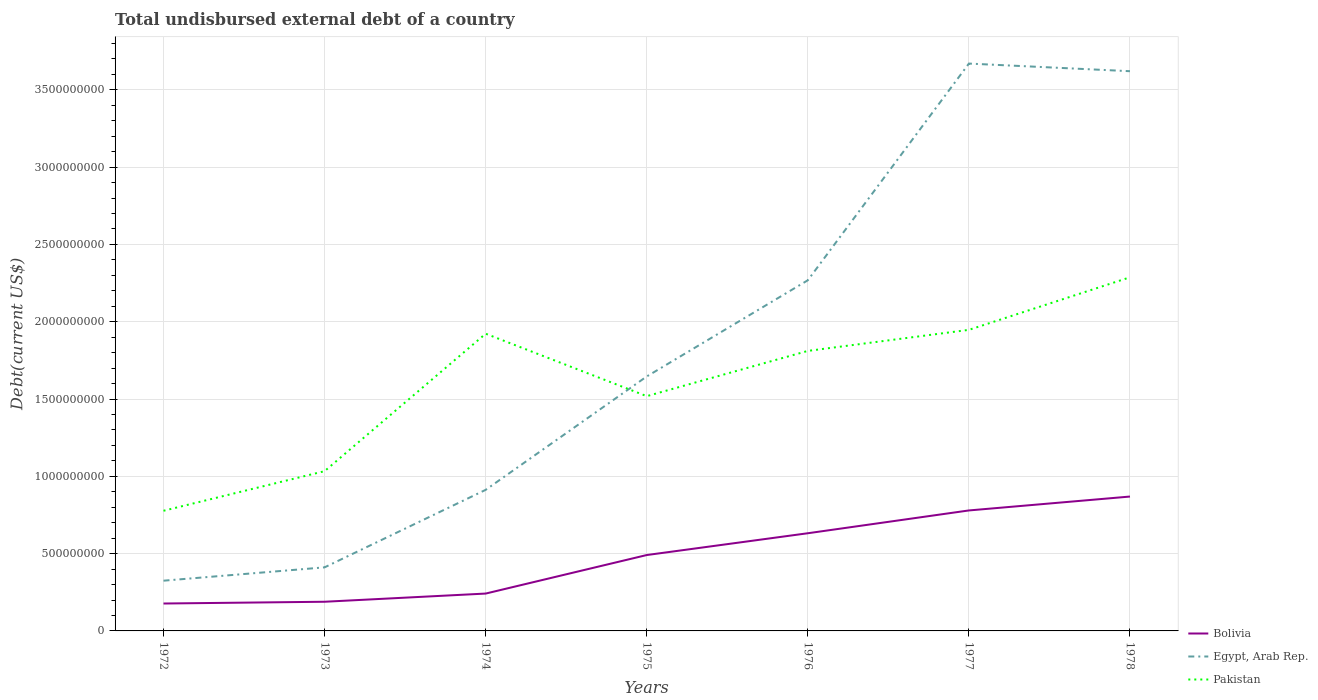Does the line corresponding to Bolivia intersect with the line corresponding to Pakistan?
Your response must be concise. No. Across all years, what is the maximum total undisbursed external debt in Egypt, Arab Rep.?
Offer a very short reply. 3.25e+08. In which year was the total undisbursed external debt in Egypt, Arab Rep. maximum?
Keep it short and to the point. 1972. What is the total total undisbursed external debt in Egypt, Arab Rep. in the graph?
Keep it short and to the point. -1.94e+09. What is the difference between the highest and the second highest total undisbursed external debt in Pakistan?
Your response must be concise. 1.51e+09. What is the difference between the highest and the lowest total undisbursed external debt in Pakistan?
Your answer should be very brief. 4. How many years are there in the graph?
Offer a terse response. 7. What is the difference between two consecutive major ticks on the Y-axis?
Keep it short and to the point. 5.00e+08. Does the graph contain any zero values?
Make the answer very short. No. Does the graph contain grids?
Provide a succinct answer. Yes. Where does the legend appear in the graph?
Your response must be concise. Bottom right. How many legend labels are there?
Make the answer very short. 3. What is the title of the graph?
Offer a terse response. Total undisbursed external debt of a country. Does "Brunei Darussalam" appear as one of the legend labels in the graph?
Give a very brief answer. No. What is the label or title of the X-axis?
Make the answer very short. Years. What is the label or title of the Y-axis?
Provide a short and direct response. Debt(current US$). What is the Debt(current US$) of Bolivia in 1972?
Provide a succinct answer. 1.77e+08. What is the Debt(current US$) of Egypt, Arab Rep. in 1972?
Provide a succinct answer. 3.25e+08. What is the Debt(current US$) of Pakistan in 1972?
Your answer should be very brief. 7.77e+08. What is the Debt(current US$) of Bolivia in 1973?
Give a very brief answer. 1.89e+08. What is the Debt(current US$) of Egypt, Arab Rep. in 1973?
Provide a short and direct response. 4.11e+08. What is the Debt(current US$) of Pakistan in 1973?
Provide a succinct answer. 1.03e+09. What is the Debt(current US$) of Bolivia in 1974?
Give a very brief answer. 2.42e+08. What is the Debt(current US$) in Egypt, Arab Rep. in 1974?
Your answer should be compact. 9.13e+08. What is the Debt(current US$) in Pakistan in 1974?
Offer a terse response. 1.92e+09. What is the Debt(current US$) of Bolivia in 1975?
Provide a short and direct response. 4.91e+08. What is the Debt(current US$) in Egypt, Arab Rep. in 1975?
Keep it short and to the point. 1.65e+09. What is the Debt(current US$) of Pakistan in 1975?
Make the answer very short. 1.52e+09. What is the Debt(current US$) in Bolivia in 1976?
Your answer should be very brief. 6.32e+08. What is the Debt(current US$) in Egypt, Arab Rep. in 1976?
Give a very brief answer. 2.27e+09. What is the Debt(current US$) of Pakistan in 1976?
Make the answer very short. 1.81e+09. What is the Debt(current US$) in Bolivia in 1977?
Provide a succinct answer. 7.79e+08. What is the Debt(current US$) in Egypt, Arab Rep. in 1977?
Offer a very short reply. 3.67e+09. What is the Debt(current US$) in Pakistan in 1977?
Offer a very short reply. 1.95e+09. What is the Debt(current US$) of Bolivia in 1978?
Your response must be concise. 8.69e+08. What is the Debt(current US$) in Egypt, Arab Rep. in 1978?
Ensure brevity in your answer.  3.62e+09. What is the Debt(current US$) in Pakistan in 1978?
Provide a succinct answer. 2.29e+09. Across all years, what is the maximum Debt(current US$) of Bolivia?
Your answer should be compact. 8.69e+08. Across all years, what is the maximum Debt(current US$) in Egypt, Arab Rep.?
Make the answer very short. 3.67e+09. Across all years, what is the maximum Debt(current US$) of Pakistan?
Give a very brief answer. 2.29e+09. Across all years, what is the minimum Debt(current US$) of Bolivia?
Offer a very short reply. 1.77e+08. Across all years, what is the minimum Debt(current US$) in Egypt, Arab Rep.?
Make the answer very short. 3.25e+08. Across all years, what is the minimum Debt(current US$) of Pakistan?
Provide a succinct answer. 7.77e+08. What is the total Debt(current US$) in Bolivia in the graph?
Give a very brief answer. 3.38e+09. What is the total Debt(current US$) in Egypt, Arab Rep. in the graph?
Keep it short and to the point. 1.29e+1. What is the total Debt(current US$) of Pakistan in the graph?
Your answer should be very brief. 1.13e+1. What is the difference between the Debt(current US$) of Bolivia in 1972 and that in 1973?
Offer a very short reply. -1.14e+07. What is the difference between the Debt(current US$) in Egypt, Arab Rep. in 1972 and that in 1973?
Offer a very short reply. -8.63e+07. What is the difference between the Debt(current US$) in Pakistan in 1972 and that in 1973?
Provide a succinct answer. -2.56e+08. What is the difference between the Debt(current US$) of Bolivia in 1972 and that in 1974?
Your answer should be compact. -6.43e+07. What is the difference between the Debt(current US$) of Egypt, Arab Rep. in 1972 and that in 1974?
Offer a terse response. -5.88e+08. What is the difference between the Debt(current US$) in Pakistan in 1972 and that in 1974?
Provide a short and direct response. -1.15e+09. What is the difference between the Debt(current US$) in Bolivia in 1972 and that in 1975?
Keep it short and to the point. -3.14e+08. What is the difference between the Debt(current US$) in Egypt, Arab Rep. in 1972 and that in 1975?
Give a very brief answer. -1.32e+09. What is the difference between the Debt(current US$) in Pakistan in 1972 and that in 1975?
Your response must be concise. -7.41e+08. What is the difference between the Debt(current US$) of Bolivia in 1972 and that in 1976?
Ensure brevity in your answer.  -4.54e+08. What is the difference between the Debt(current US$) of Egypt, Arab Rep. in 1972 and that in 1976?
Your answer should be compact. -1.94e+09. What is the difference between the Debt(current US$) of Pakistan in 1972 and that in 1976?
Offer a terse response. -1.03e+09. What is the difference between the Debt(current US$) in Bolivia in 1972 and that in 1977?
Keep it short and to the point. -6.02e+08. What is the difference between the Debt(current US$) in Egypt, Arab Rep. in 1972 and that in 1977?
Offer a very short reply. -3.34e+09. What is the difference between the Debt(current US$) of Pakistan in 1972 and that in 1977?
Keep it short and to the point. -1.17e+09. What is the difference between the Debt(current US$) in Bolivia in 1972 and that in 1978?
Offer a terse response. -6.92e+08. What is the difference between the Debt(current US$) in Egypt, Arab Rep. in 1972 and that in 1978?
Your answer should be compact. -3.30e+09. What is the difference between the Debt(current US$) of Pakistan in 1972 and that in 1978?
Your answer should be very brief. -1.51e+09. What is the difference between the Debt(current US$) of Bolivia in 1973 and that in 1974?
Keep it short and to the point. -5.29e+07. What is the difference between the Debt(current US$) of Egypt, Arab Rep. in 1973 and that in 1974?
Provide a short and direct response. -5.01e+08. What is the difference between the Debt(current US$) of Pakistan in 1973 and that in 1974?
Offer a very short reply. -8.89e+08. What is the difference between the Debt(current US$) in Bolivia in 1973 and that in 1975?
Give a very brief answer. -3.02e+08. What is the difference between the Debt(current US$) of Egypt, Arab Rep. in 1973 and that in 1975?
Provide a short and direct response. -1.23e+09. What is the difference between the Debt(current US$) in Pakistan in 1973 and that in 1975?
Provide a short and direct response. -4.85e+08. What is the difference between the Debt(current US$) in Bolivia in 1973 and that in 1976?
Make the answer very short. -4.43e+08. What is the difference between the Debt(current US$) in Egypt, Arab Rep. in 1973 and that in 1976?
Provide a succinct answer. -1.86e+09. What is the difference between the Debt(current US$) in Pakistan in 1973 and that in 1976?
Keep it short and to the point. -7.78e+08. What is the difference between the Debt(current US$) in Bolivia in 1973 and that in 1977?
Your answer should be compact. -5.91e+08. What is the difference between the Debt(current US$) in Egypt, Arab Rep. in 1973 and that in 1977?
Your answer should be very brief. -3.26e+09. What is the difference between the Debt(current US$) in Pakistan in 1973 and that in 1977?
Your response must be concise. -9.14e+08. What is the difference between the Debt(current US$) of Bolivia in 1973 and that in 1978?
Provide a short and direct response. -6.80e+08. What is the difference between the Debt(current US$) of Egypt, Arab Rep. in 1973 and that in 1978?
Your answer should be very brief. -3.21e+09. What is the difference between the Debt(current US$) of Pakistan in 1973 and that in 1978?
Your answer should be very brief. -1.25e+09. What is the difference between the Debt(current US$) of Bolivia in 1974 and that in 1975?
Ensure brevity in your answer.  -2.49e+08. What is the difference between the Debt(current US$) in Egypt, Arab Rep. in 1974 and that in 1975?
Make the answer very short. -7.33e+08. What is the difference between the Debt(current US$) of Pakistan in 1974 and that in 1975?
Your answer should be very brief. 4.04e+08. What is the difference between the Debt(current US$) in Bolivia in 1974 and that in 1976?
Your answer should be compact. -3.90e+08. What is the difference between the Debt(current US$) in Egypt, Arab Rep. in 1974 and that in 1976?
Provide a short and direct response. -1.36e+09. What is the difference between the Debt(current US$) in Pakistan in 1974 and that in 1976?
Make the answer very short. 1.11e+08. What is the difference between the Debt(current US$) in Bolivia in 1974 and that in 1977?
Keep it short and to the point. -5.38e+08. What is the difference between the Debt(current US$) in Egypt, Arab Rep. in 1974 and that in 1977?
Offer a terse response. -2.76e+09. What is the difference between the Debt(current US$) of Pakistan in 1974 and that in 1977?
Your answer should be compact. -2.50e+07. What is the difference between the Debt(current US$) in Bolivia in 1974 and that in 1978?
Your answer should be very brief. -6.28e+08. What is the difference between the Debt(current US$) in Egypt, Arab Rep. in 1974 and that in 1978?
Make the answer very short. -2.71e+09. What is the difference between the Debt(current US$) in Pakistan in 1974 and that in 1978?
Offer a very short reply. -3.65e+08. What is the difference between the Debt(current US$) of Bolivia in 1975 and that in 1976?
Your answer should be very brief. -1.41e+08. What is the difference between the Debt(current US$) in Egypt, Arab Rep. in 1975 and that in 1976?
Provide a succinct answer. -6.22e+08. What is the difference between the Debt(current US$) in Pakistan in 1975 and that in 1976?
Provide a short and direct response. -2.93e+08. What is the difference between the Debt(current US$) in Bolivia in 1975 and that in 1977?
Provide a short and direct response. -2.88e+08. What is the difference between the Debt(current US$) of Egypt, Arab Rep. in 1975 and that in 1977?
Your response must be concise. -2.02e+09. What is the difference between the Debt(current US$) in Pakistan in 1975 and that in 1977?
Offer a very short reply. -4.29e+08. What is the difference between the Debt(current US$) in Bolivia in 1975 and that in 1978?
Your answer should be compact. -3.78e+08. What is the difference between the Debt(current US$) in Egypt, Arab Rep. in 1975 and that in 1978?
Ensure brevity in your answer.  -1.97e+09. What is the difference between the Debt(current US$) of Pakistan in 1975 and that in 1978?
Your answer should be very brief. -7.69e+08. What is the difference between the Debt(current US$) of Bolivia in 1976 and that in 1977?
Your answer should be very brief. -1.47e+08. What is the difference between the Debt(current US$) of Egypt, Arab Rep. in 1976 and that in 1977?
Ensure brevity in your answer.  -1.40e+09. What is the difference between the Debt(current US$) in Pakistan in 1976 and that in 1977?
Ensure brevity in your answer.  -1.36e+08. What is the difference between the Debt(current US$) of Bolivia in 1976 and that in 1978?
Keep it short and to the point. -2.37e+08. What is the difference between the Debt(current US$) in Egypt, Arab Rep. in 1976 and that in 1978?
Provide a succinct answer. -1.35e+09. What is the difference between the Debt(current US$) of Pakistan in 1976 and that in 1978?
Keep it short and to the point. -4.76e+08. What is the difference between the Debt(current US$) of Bolivia in 1977 and that in 1978?
Your answer should be very brief. -8.99e+07. What is the difference between the Debt(current US$) in Egypt, Arab Rep. in 1977 and that in 1978?
Your response must be concise. 4.94e+07. What is the difference between the Debt(current US$) in Pakistan in 1977 and that in 1978?
Your answer should be very brief. -3.40e+08. What is the difference between the Debt(current US$) of Bolivia in 1972 and the Debt(current US$) of Egypt, Arab Rep. in 1973?
Provide a short and direct response. -2.34e+08. What is the difference between the Debt(current US$) in Bolivia in 1972 and the Debt(current US$) in Pakistan in 1973?
Make the answer very short. -8.56e+08. What is the difference between the Debt(current US$) of Egypt, Arab Rep. in 1972 and the Debt(current US$) of Pakistan in 1973?
Make the answer very short. -7.09e+08. What is the difference between the Debt(current US$) of Bolivia in 1972 and the Debt(current US$) of Egypt, Arab Rep. in 1974?
Provide a short and direct response. -7.35e+08. What is the difference between the Debt(current US$) in Bolivia in 1972 and the Debt(current US$) in Pakistan in 1974?
Provide a succinct answer. -1.75e+09. What is the difference between the Debt(current US$) in Egypt, Arab Rep. in 1972 and the Debt(current US$) in Pakistan in 1974?
Provide a short and direct response. -1.60e+09. What is the difference between the Debt(current US$) in Bolivia in 1972 and the Debt(current US$) in Egypt, Arab Rep. in 1975?
Provide a short and direct response. -1.47e+09. What is the difference between the Debt(current US$) of Bolivia in 1972 and the Debt(current US$) of Pakistan in 1975?
Your answer should be very brief. -1.34e+09. What is the difference between the Debt(current US$) in Egypt, Arab Rep. in 1972 and the Debt(current US$) in Pakistan in 1975?
Offer a terse response. -1.19e+09. What is the difference between the Debt(current US$) in Bolivia in 1972 and the Debt(current US$) in Egypt, Arab Rep. in 1976?
Keep it short and to the point. -2.09e+09. What is the difference between the Debt(current US$) in Bolivia in 1972 and the Debt(current US$) in Pakistan in 1976?
Provide a short and direct response. -1.63e+09. What is the difference between the Debt(current US$) in Egypt, Arab Rep. in 1972 and the Debt(current US$) in Pakistan in 1976?
Keep it short and to the point. -1.49e+09. What is the difference between the Debt(current US$) in Bolivia in 1972 and the Debt(current US$) in Egypt, Arab Rep. in 1977?
Provide a short and direct response. -3.49e+09. What is the difference between the Debt(current US$) of Bolivia in 1972 and the Debt(current US$) of Pakistan in 1977?
Your answer should be very brief. -1.77e+09. What is the difference between the Debt(current US$) in Egypt, Arab Rep. in 1972 and the Debt(current US$) in Pakistan in 1977?
Keep it short and to the point. -1.62e+09. What is the difference between the Debt(current US$) of Bolivia in 1972 and the Debt(current US$) of Egypt, Arab Rep. in 1978?
Give a very brief answer. -3.44e+09. What is the difference between the Debt(current US$) in Bolivia in 1972 and the Debt(current US$) in Pakistan in 1978?
Give a very brief answer. -2.11e+09. What is the difference between the Debt(current US$) in Egypt, Arab Rep. in 1972 and the Debt(current US$) in Pakistan in 1978?
Offer a very short reply. -1.96e+09. What is the difference between the Debt(current US$) in Bolivia in 1973 and the Debt(current US$) in Egypt, Arab Rep. in 1974?
Keep it short and to the point. -7.24e+08. What is the difference between the Debt(current US$) in Bolivia in 1973 and the Debt(current US$) in Pakistan in 1974?
Your response must be concise. -1.73e+09. What is the difference between the Debt(current US$) of Egypt, Arab Rep. in 1973 and the Debt(current US$) of Pakistan in 1974?
Make the answer very short. -1.51e+09. What is the difference between the Debt(current US$) in Bolivia in 1973 and the Debt(current US$) in Egypt, Arab Rep. in 1975?
Provide a succinct answer. -1.46e+09. What is the difference between the Debt(current US$) in Bolivia in 1973 and the Debt(current US$) in Pakistan in 1975?
Keep it short and to the point. -1.33e+09. What is the difference between the Debt(current US$) in Egypt, Arab Rep. in 1973 and the Debt(current US$) in Pakistan in 1975?
Provide a short and direct response. -1.11e+09. What is the difference between the Debt(current US$) of Bolivia in 1973 and the Debt(current US$) of Egypt, Arab Rep. in 1976?
Offer a terse response. -2.08e+09. What is the difference between the Debt(current US$) of Bolivia in 1973 and the Debt(current US$) of Pakistan in 1976?
Ensure brevity in your answer.  -1.62e+09. What is the difference between the Debt(current US$) in Egypt, Arab Rep. in 1973 and the Debt(current US$) in Pakistan in 1976?
Provide a succinct answer. -1.40e+09. What is the difference between the Debt(current US$) in Bolivia in 1973 and the Debt(current US$) in Egypt, Arab Rep. in 1977?
Offer a very short reply. -3.48e+09. What is the difference between the Debt(current US$) of Bolivia in 1973 and the Debt(current US$) of Pakistan in 1977?
Your response must be concise. -1.76e+09. What is the difference between the Debt(current US$) in Egypt, Arab Rep. in 1973 and the Debt(current US$) in Pakistan in 1977?
Make the answer very short. -1.54e+09. What is the difference between the Debt(current US$) in Bolivia in 1973 and the Debt(current US$) in Egypt, Arab Rep. in 1978?
Give a very brief answer. -3.43e+09. What is the difference between the Debt(current US$) in Bolivia in 1973 and the Debt(current US$) in Pakistan in 1978?
Offer a terse response. -2.10e+09. What is the difference between the Debt(current US$) in Egypt, Arab Rep. in 1973 and the Debt(current US$) in Pakistan in 1978?
Offer a terse response. -1.88e+09. What is the difference between the Debt(current US$) in Bolivia in 1974 and the Debt(current US$) in Egypt, Arab Rep. in 1975?
Your answer should be very brief. -1.40e+09. What is the difference between the Debt(current US$) of Bolivia in 1974 and the Debt(current US$) of Pakistan in 1975?
Provide a short and direct response. -1.28e+09. What is the difference between the Debt(current US$) of Egypt, Arab Rep. in 1974 and the Debt(current US$) of Pakistan in 1975?
Your answer should be compact. -6.06e+08. What is the difference between the Debt(current US$) in Bolivia in 1974 and the Debt(current US$) in Egypt, Arab Rep. in 1976?
Keep it short and to the point. -2.03e+09. What is the difference between the Debt(current US$) of Bolivia in 1974 and the Debt(current US$) of Pakistan in 1976?
Offer a terse response. -1.57e+09. What is the difference between the Debt(current US$) in Egypt, Arab Rep. in 1974 and the Debt(current US$) in Pakistan in 1976?
Keep it short and to the point. -8.99e+08. What is the difference between the Debt(current US$) of Bolivia in 1974 and the Debt(current US$) of Egypt, Arab Rep. in 1977?
Your answer should be very brief. -3.43e+09. What is the difference between the Debt(current US$) in Bolivia in 1974 and the Debt(current US$) in Pakistan in 1977?
Offer a terse response. -1.71e+09. What is the difference between the Debt(current US$) of Egypt, Arab Rep. in 1974 and the Debt(current US$) of Pakistan in 1977?
Offer a terse response. -1.03e+09. What is the difference between the Debt(current US$) in Bolivia in 1974 and the Debt(current US$) in Egypt, Arab Rep. in 1978?
Offer a terse response. -3.38e+09. What is the difference between the Debt(current US$) of Bolivia in 1974 and the Debt(current US$) of Pakistan in 1978?
Offer a terse response. -2.05e+09. What is the difference between the Debt(current US$) in Egypt, Arab Rep. in 1974 and the Debt(current US$) in Pakistan in 1978?
Offer a very short reply. -1.37e+09. What is the difference between the Debt(current US$) in Bolivia in 1975 and the Debt(current US$) in Egypt, Arab Rep. in 1976?
Make the answer very short. -1.78e+09. What is the difference between the Debt(current US$) in Bolivia in 1975 and the Debt(current US$) in Pakistan in 1976?
Make the answer very short. -1.32e+09. What is the difference between the Debt(current US$) in Egypt, Arab Rep. in 1975 and the Debt(current US$) in Pakistan in 1976?
Provide a succinct answer. -1.65e+08. What is the difference between the Debt(current US$) in Bolivia in 1975 and the Debt(current US$) in Egypt, Arab Rep. in 1977?
Your answer should be very brief. -3.18e+09. What is the difference between the Debt(current US$) of Bolivia in 1975 and the Debt(current US$) of Pakistan in 1977?
Provide a succinct answer. -1.46e+09. What is the difference between the Debt(current US$) of Egypt, Arab Rep. in 1975 and the Debt(current US$) of Pakistan in 1977?
Offer a terse response. -3.02e+08. What is the difference between the Debt(current US$) in Bolivia in 1975 and the Debt(current US$) in Egypt, Arab Rep. in 1978?
Offer a very short reply. -3.13e+09. What is the difference between the Debt(current US$) in Bolivia in 1975 and the Debt(current US$) in Pakistan in 1978?
Ensure brevity in your answer.  -1.80e+09. What is the difference between the Debt(current US$) in Egypt, Arab Rep. in 1975 and the Debt(current US$) in Pakistan in 1978?
Offer a very short reply. -6.41e+08. What is the difference between the Debt(current US$) of Bolivia in 1976 and the Debt(current US$) of Egypt, Arab Rep. in 1977?
Make the answer very short. -3.04e+09. What is the difference between the Debt(current US$) in Bolivia in 1976 and the Debt(current US$) in Pakistan in 1977?
Provide a short and direct response. -1.32e+09. What is the difference between the Debt(current US$) of Egypt, Arab Rep. in 1976 and the Debt(current US$) of Pakistan in 1977?
Your answer should be compact. 3.21e+08. What is the difference between the Debt(current US$) of Bolivia in 1976 and the Debt(current US$) of Egypt, Arab Rep. in 1978?
Offer a terse response. -2.99e+09. What is the difference between the Debt(current US$) of Bolivia in 1976 and the Debt(current US$) of Pakistan in 1978?
Give a very brief answer. -1.66e+09. What is the difference between the Debt(current US$) in Egypt, Arab Rep. in 1976 and the Debt(current US$) in Pakistan in 1978?
Your answer should be compact. -1.92e+07. What is the difference between the Debt(current US$) of Bolivia in 1977 and the Debt(current US$) of Egypt, Arab Rep. in 1978?
Provide a short and direct response. -2.84e+09. What is the difference between the Debt(current US$) in Bolivia in 1977 and the Debt(current US$) in Pakistan in 1978?
Ensure brevity in your answer.  -1.51e+09. What is the difference between the Debt(current US$) of Egypt, Arab Rep. in 1977 and the Debt(current US$) of Pakistan in 1978?
Give a very brief answer. 1.38e+09. What is the average Debt(current US$) of Bolivia per year?
Keep it short and to the point. 4.83e+08. What is the average Debt(current US$) of Egypt, Arab Rep. per year?
Offer a terse response. 1.84e+09. What is the average Debt(current US$) of Pakistan per year?
Provide a succinct answer. 1.61e+09. In the year 1972, what is the difference between the Debt(current US$) in Bolivia and Debt(current US$) in Egypt, Arab Rep.?
Offer a terse response. -1.48e+08. In the year 1972, what is the difference between the Debt(current US$) of Bolivia and Debt(current US$) of Pakistan?
Make the answer very short. -6.00e+08. In the year 1972, what is the difference between the Debt(current US$) of Egypt, Arab Rep. and Debt(current US$) of Pakistan?
Ensure brevity in your answer.  -4.52e+08. In the year 1973, what is the difference between the Debt(current US$) of Bolivia and Debt(current US$) of Egypt, Arab Rep.?
Your answer should be very brief. -2.23e+08. In the year 1973, what is the difference between the Debt(current US$) in Bolivia and Debt(current US$) in Pakistan?
Provide a succinct answer. -8.45e+08. In the year 1973, what is the difference between the Debt(current US$) in Egypt, Arab Rep. and Debt(current US$) in Pakistan?
Your response must be concise. -6.22e+08. In the year 1974, what is the difference between the Debt(current US$) of Bolivia and Debt(current US$) of Egypt, Arab Rep.?
Offer a very short reply. -6.71e+08. In the year 1974, what is the difference between the Debt(current US$) in Bolivia and Debt(current US$) in Pakistan?
Give a very brief answer. -1.68e+09. In the year 1974, what is the difference between the Debt(current US$) in Egypt, Arab Rep. and Debt(current US$) in Pakistan?
Make the answer very short. -1.01e+09. In the year 1975, what is the difference between the Debt(current US$) in Bolivia and Debt(current US$) in Egypt, Arab Rep.?
Ensure brevity in your answer.  -1.16e+09. In the year 1975, what is the difference between the Debt(current US$) in Bolivia and Debt(current US$) in Pakistan?
Offer a very short reply. -1.03e+09. In the year 1975, what is the difference between the Debt(current US$) in Egypt, Arab Rep. and Debt(current US$) in Pakistan?
Give a very brief answer. 1.27e+08. In the year 1976, what is the difference between the Debt(current US$) of Bolivia and Debt(current US$) of Egypt, Arab Rep.?
Offer a terse response. -1.64e+09. In the year 1976, what is the difference between the Debt(current US$) in Bolivia and Debt(current US$) in Pakistan?
Give a very brief answer. -1.18e+09. In the year 1976, what is the difference between the Debt(current US$) in Egypt, Arab Rep. and Debt(current US$) in Pakistan?
Provide a short and direct response. 4.57e+08. In the year 1977, what is the difference between the Debt(current US$) in Bolivia and Debt(current US$) in Egypt, Arab Rep.?
Your answer should be very brief. -2.89e+09. In the year 1977, what is the difference between the Debt(current US$) of Bolivia and Debt(current US$) of Pakistan?
Make the answer very short. -1.17e+09. In the year 1977, what is the difference between the Debt(current US$) in Egypt, Arab Rep. and Debt(current US$) in Pakistan?
Provide a succinct answer. 1.72e+09. In the year 1978, what is the difference between the Debt(current US$) of Bolivia and Debt(current US$) of Egypt, Arab Rep.?
Make the answer very short. -2.75e+09. In the year 1978, what is the difference between the Debt(current US$) in Bolivia and Debt(current US$) in Pakistan?
Your answer should be very brief. -1.42e+09. In the year 1978, what is the difference between the Debt(current US$) in Egypt, Arab Rep. and Debt(current US$) in Pakistan?
Offer a very short reply. 1.33e+09. What is the ratio of the Debt(current US$) of Bolivia in 1972 to that in 1973?
Give a very brief answer. 0.94. What is the ratio of the Debt(current US$) in Egypt, Arab Rep. in 1972 to that in 1973?
Offer a terse response. 0.79. What is the ratio of the Debt(current US$) of Pakistan in 1972 to that in 1973?
Provide a short and direct response. 0.75. What is the ratio of the Debt(current US$) in Bolivia in 1972 to that in 1974?
Keep it short and to the point. 0.73. What is the ratio of the Debt(current US$) in Egypt, Arab Rep. in 1972 to that in 1974?
Provide a succinct answer. 0.36. What is the ratio of the Debt(current US$) in Pakistan in 1972 to that in 1974?
Ensure brevity in your answer.  0.4. What is the ratio of the Debt(current US$) in Bolivia in 1972 to that in 1975?
Ensure brevity in your answer.  0.36. What is the ratio of the Debt(current US$) in Egypt, Arab Rep. in 1972 to that in 1975?
Provide a succinct answer. 0.2. What is the ratio of the Debt(current US$) in Pakistan in 1972 to that in 1975?
Keep it short and to the point. 0.51. What is the ratio of the Debt(current US$) of Bolivia in 1972 to that in 1976?
Offer a very short reply. 0.28. What is the ratio of the Debt(current US$) of Egypt, Arab Rep. in 1972 to that in 1976?
Make the answer very short. 0.14. What is the ratio of the Debt(current US$) in Pakistan in 1972 to that in 1976?
Your answer should be very brief. 0.43. What is the ratio of the Debt(current US$) in Bolivia in 1972 to that in 1977?
Your response must be concise. 0.23. What is the ratio of the Debt(current US$) in Egypt, Arab Rep. in 1972 to that in 1977?
Provide a succinct answer. 0.09. What is the ratio of the Debt(current US$) of Pakistan in 1972 to that in 1977?
Ensure brevity in your answer.  0.4. What is the ratio of the Debt(current US$) of Bolivia in 1972 to that in 1978?
Offer a terse response. 0.2. What is the ratio of the Debt(current US$) of Egypt, Arab Rep. in 1972 to that in 1978?
Ensure brevity in your answer.  0.09. What is the ratio of the Debt(current US$) in Pakistan in 1972 to that in 1978?
Your response must be concise. 0.34. What is the ratio of the Debt(current US$) of Bolivia in 1973 to that in 1974?
Make the answer very short. 0.78. What is the ratio of the Debt(current US$) in Egypt, Arab Rep. in 1973 to that in 1974?
Offer a very short reply. 0.45. What is the ratio of the Debt(current US$) in Pakistan in 1973 to that in 1974?
Offer a very short reply. 0.54. What is the ratio of the Debt(current US$) of Bolivia in 1973 to that in 1975?
Keep it short and to the point. 0.38. What is the ratio of the Debt(current US$) of Egypt, Arab Rep. in 1973 to that in 1975?
Your answer should be very brief. 0.25. What is the ratio of the Debt(current US$) of Pakistan in 1973 to that in 1975?
Make the answer very short. 0.68. What is the ratio of the Debt(current US$) of Bolivia in 1973 to that in 1976?
Your answer should be very brief. 0.3. What is the ratio of the Debt(current US$) in Egypt, Arab Rep. in 1973 to that in 1976?
Your answer should be compact. 0.18. What is the ratio of the Debt(current US$) of Pakistan in 1973 to that in 1976?
Offer a very short reply. 0.57. What is the ratio of the Debt(current US$) in Bolivia in 1973 to that in 1977?
Offer a terse response. 0.24. What is the ratio of the Debt(current US$) in Egypt, Arab Rep. in 1973 to that in 1977?
Your answer should be compact. 0.11. What is the ratio of the Debt(current US$) in Pakistan in 1973 to that in 1977?
Provide a succinct answer. 0.53. What is the ratio of the Debt(current US$) of Bolivia in 1973 to that in 1978?
Offer a very short reply. 0.22. What is the ratio of the Debt(current US$) of Egypt, Arab Rep. in 1973 to that in 1978?
Keep it short and to the point. 0.11. What is the ratio of the Debt(current US$) of Pakistan in 1973 to that in 1978?
Offer a very short reply. 0.45. What is the ratio of the Debt(current US$) of Bolivia in 1974 to that in 1975?
Offer a very short reply. 0.49. What is the ratio of the Debt(current US$) in Egypt, Arab Rep. in 1974 to that in 1975?
Offer a terse response. 0.55. What is the ratio of the Debt(current US$) in Pakistan in 1974 to that in 1975?
Your answer should be very brief. 1.27. What is the ratio of the Debt(current US$) of Bolivia in 1974 to that in 1976?
Keep it short and to the point. 0.38. What is the ratio of the Debt(current US$) of Egypt, Arab Rep. in 1974 to that in 1976?
Give a very brief answer. 0.4. What is the ratio of the Debt(current US$) in Pakistan in 1974 to that in 1976?
Offer a terse response. 1.06. What is the ratio of the Debt(current US$) in Bolivia in 1974 to that in 1977?
Offer a very short reply. 0.31. What is the ratio of the Debt(current US$) in Egypt, Arab Rep. in 1974 to that in 1977?
Keep it short and to the point. 0.25. What is the ratio of the Debt(current US$) in Pakistan in 1974 to that in 1977?
Keep it short and to the point. 0.99. What is the ratio of the Debt(current US$) of Bolivia in 1974 to that in 1978?
Offer a very short reply. 0.28. What is the ratio of the Debt(current US$) of Egypt, Arab Rep. in 1974 to that in 1978?
Provide a succinct answer. 0.25. What is the ratio of the Debt(current US$) of Pakistan in 1974 to that in 1978?
Offer a terse response. 0.84. What is the ratio of the Debt(current US$) of Bolivia in 1975 to that in 1976?
Your answer should be very brief. 0.78. What is the ratio of the Debt(current US$) in Egypt, Arab Rep. in 1975 to that in 1976?
Offer a very short reply. 0.73. What is the ratio of the Debt(current US$) in Pakistan in 1975 to that in 1976?
Your answer should be compact. 0.84. What is the ratio of the Debt(current US$) of Bolivia in 1975 to that in 1977?
Make the answer very short. 0.63. What is the ratio of the Debt(current US$) in Egypt, Arab Rep. in 1975 to that in 1977?
Your response must be concise. 0.45. What is the ratio of the Debt(current US$) in Pakistan in 1975 to that in 1977?
Provide a succinct answer. 0.78. What is the ratio of the Debt(current US$) of Bolivia in 1975 to that in 1978?
Provide a short and direct response. 0.56. What is the ratio of the Debt(current US$) in Egypt, Arab Rep. in 1975 to that in 1978?
Keep it short and to the point. 0.45. What is the ratio of the Debt(current US$) in Pakistan in 1975 to that in 1978?
Offer a terse response. 0.66. What is the ratio of the Debt(current US$) of Bolivia in 1976 to that in 1977?
Ensure brevity in your answer.  0.81. What is the ratio of the Debt(current US$) of Egypt, Arab Rep. in 1976 to that in 1977?
Provide a succinct answer. 0.62. What is the ratio of the Debt(current US$) of Pakistan in 1976 to that in 1977?
Your answer should be very brief. 0.93. What is the ratio of the Debt(current US$) in Bolivia in 1976 to that in 1978?
Your answer should be compact. 0.73. What is the ratio of the Debt(current US$) in Egypt, Arab Rep. in 1976 to that in 1978?
Offer a very short reply. 0.63. What is the ratio of the Debt(current US$) of Pakistan in 1976 to that in 1978?
Ensure brevity in your answer.  0.79. What is the ratio of the Debt(current US$) of Bolivia in 1977 to that in 1978?
Provide a succinct answer. 0.9. What is the ratio of the Debt(current US$) of Egypt, Arab Rep. in 1977 to that in 1978?
Give a very brief answer. 1.01. What is the ratio of the Debt(current US$) in Pakistan in 1977 to that in 1978?
Give a very brief answer. 0.85. What is the difference between the highest and the second highest Debt(current US$) of Bolivia?
Your response must be concise. 8.99e+07. What is the difference between the highest and the second highest Debt(current US$) in Egypt, Arab Rep.?
Give a very brief answer. 4.94e+07. What is the difference between the highest and the second highest Debt(current US$) in Pakistan?
Give a very brief answer. 3.40e+08. What is the difference between the highest and the lowest Debt(current US$) in Bolivia?
Keep it short and to the point. 6.92e+08. What is the difference between the highest and the lowest Debt(current US$) in Egypt, Arab Rep.?
Ensure brevity in your answer.  3.34e+09. What is the difference between the highest and the lowest Debt(current US$) of Pakistan?
Offer a terse response. 1.51e+09. 